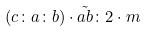<formula> <loc_0><loc_0><loc_500><loc_500>( c \colon a \colon b ) \cdot \tilde { a b } \colon 2 \cdot m</formula> 